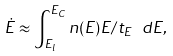Convert formula to latex. <formula><loc_0><loc_0><loc_500><loc_500>\dot { E } \approx \int _ { E _ { l } } ^ { E _ { C } } n ( E ) E / t _ { E } \ d E ,</formula> 